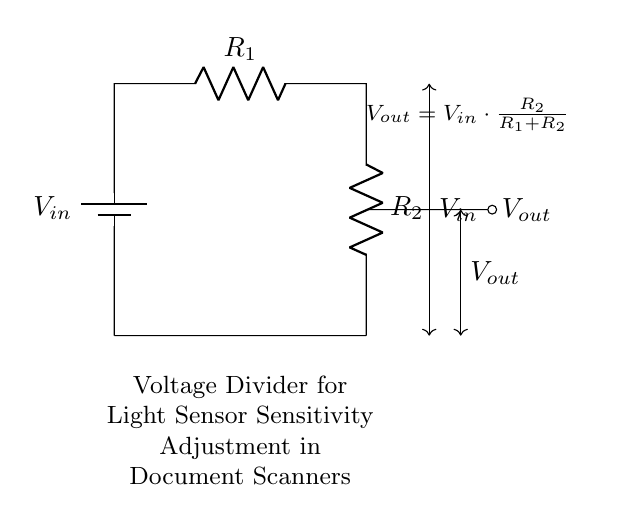What is the input voltage of the circuit? The input voltage, labeled as V in, is indicated at the top of the circuit diagram next to the battery symbol.
Answer: V in What components are used in the voltage divider? The voltage divider circuit consists of two resistors, labeled R1 and R2, and a battery symbol representing the input voltage.
Answer: Two resistors What is the formula for the output voltage? The formula for the output voltage, V out, is given in the diagram as V out equals V in multiplied by R2 over the sum of R1 and R2.
Answer: V out = V in * R2 / (R1 + R2) What happens to the output voltage when R2 is increased? If R2 is increased, it will lead to a higher value in the output voltage formula, therefore V out will increase. This can be reasoned because a larger R2 increases the fraction of V in that contributes to V out.
Answer: V out increases What is the primary function of this voltage divider circuit? The primary function of the voltage divider circuit is to adjust the sensitivity of the light sensors in document scanning equipment, allowing for fine-tuning of sensor readings.
Answer: Sensitivity adjustment What is the relationship between R1 and R2 for maximum output voltage? For maximum output voltage, R1 should be minimized, as lowering R1 increases the fraction of V in that reaches V out, maximizing its value.
Answer: R1 minimized 